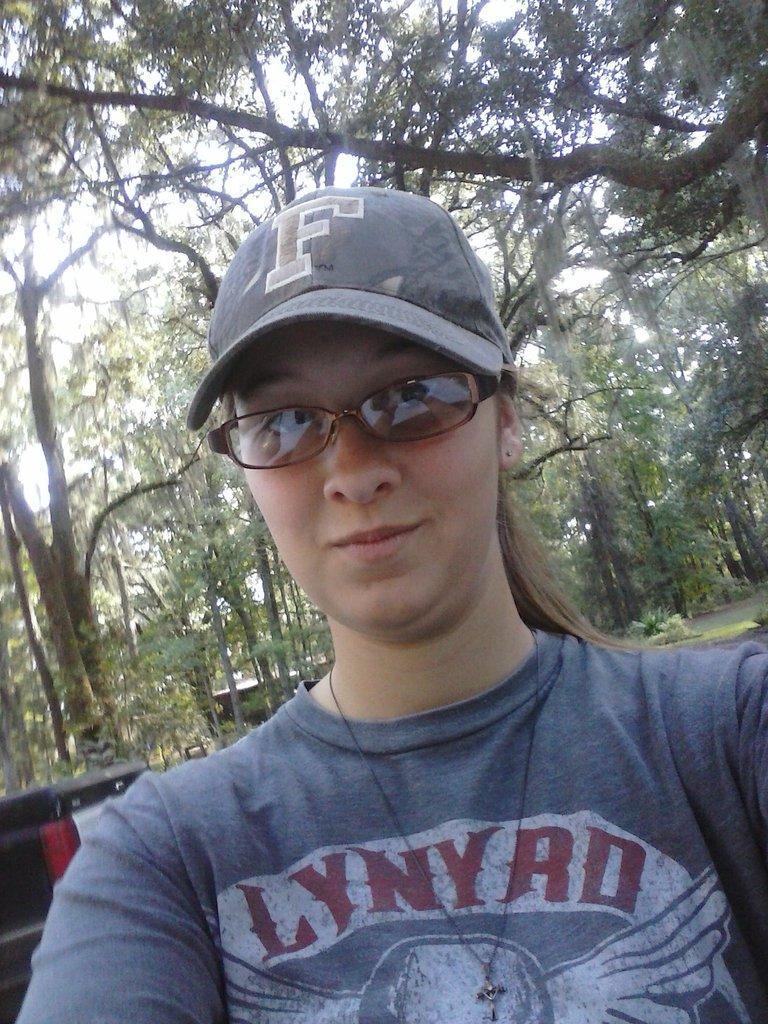How would you summarize this image in a sentence or two? In this image I can see a lady who is wearing cap and glasses, behind her there are some objects and trees. 